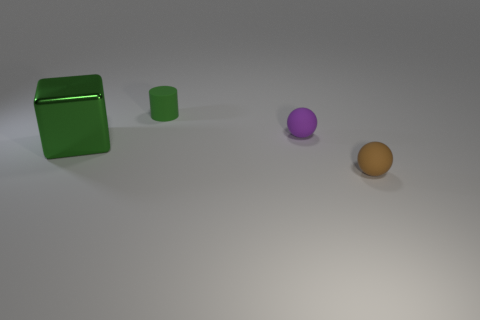Add 2 green matte objects. How many objects exist? 6 Subtract all cylinders. How many objects are left? 3 Subtract 0 brown cylinders. How many objects are left? 4 Subtract all metal cubes. Subtract all tiny purple spheres. How many objects are left? 2 Add 2 large green objects. How many large green objects are left? 3 Add 2 gray metallic objects. How many gray metallic objects exist? 2 